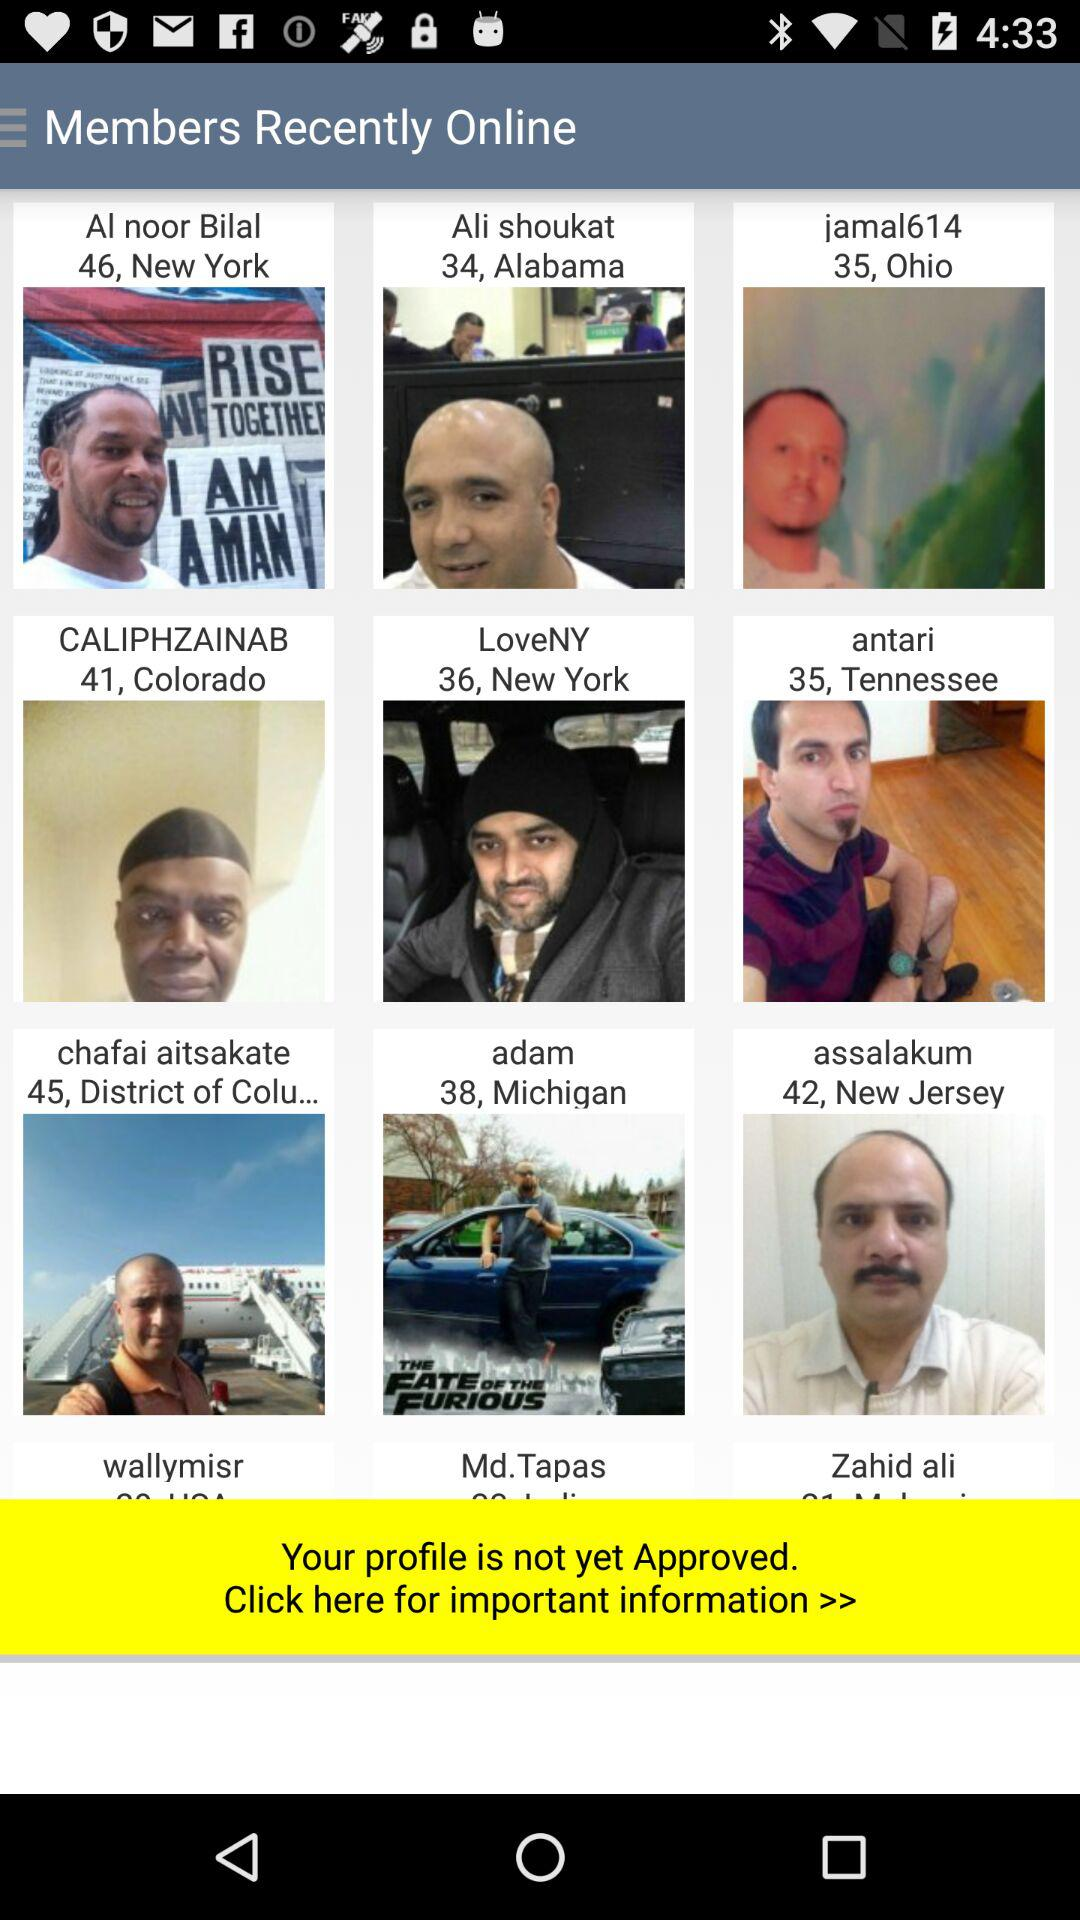What is the age of "jamal614"? The age is 35 years. 